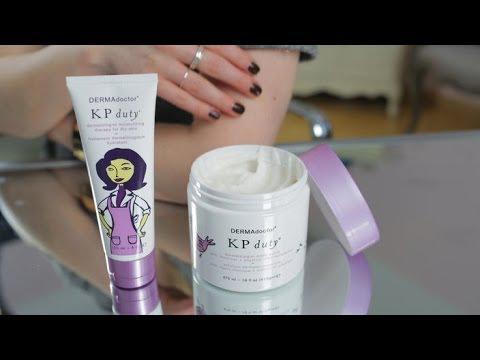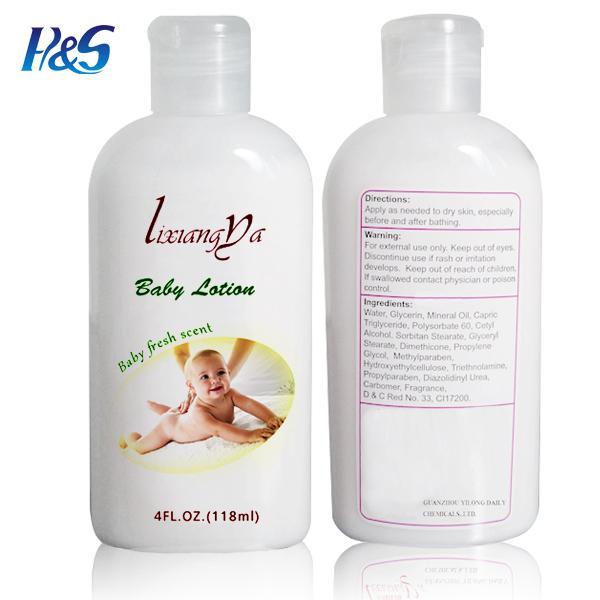The first image is the image on the left, the second image is the image on the right. Given the left and right images, does the statement "Some of the bottles in the right image have rounded tops." hold true? Answer yes or no. No. The first image is the image on the left, the second image is the image on the right. For the images displayed, is the sentence "The left image contains exactly three bottles, all of the same size and shape." factually correct? Answer yes or no. No. 